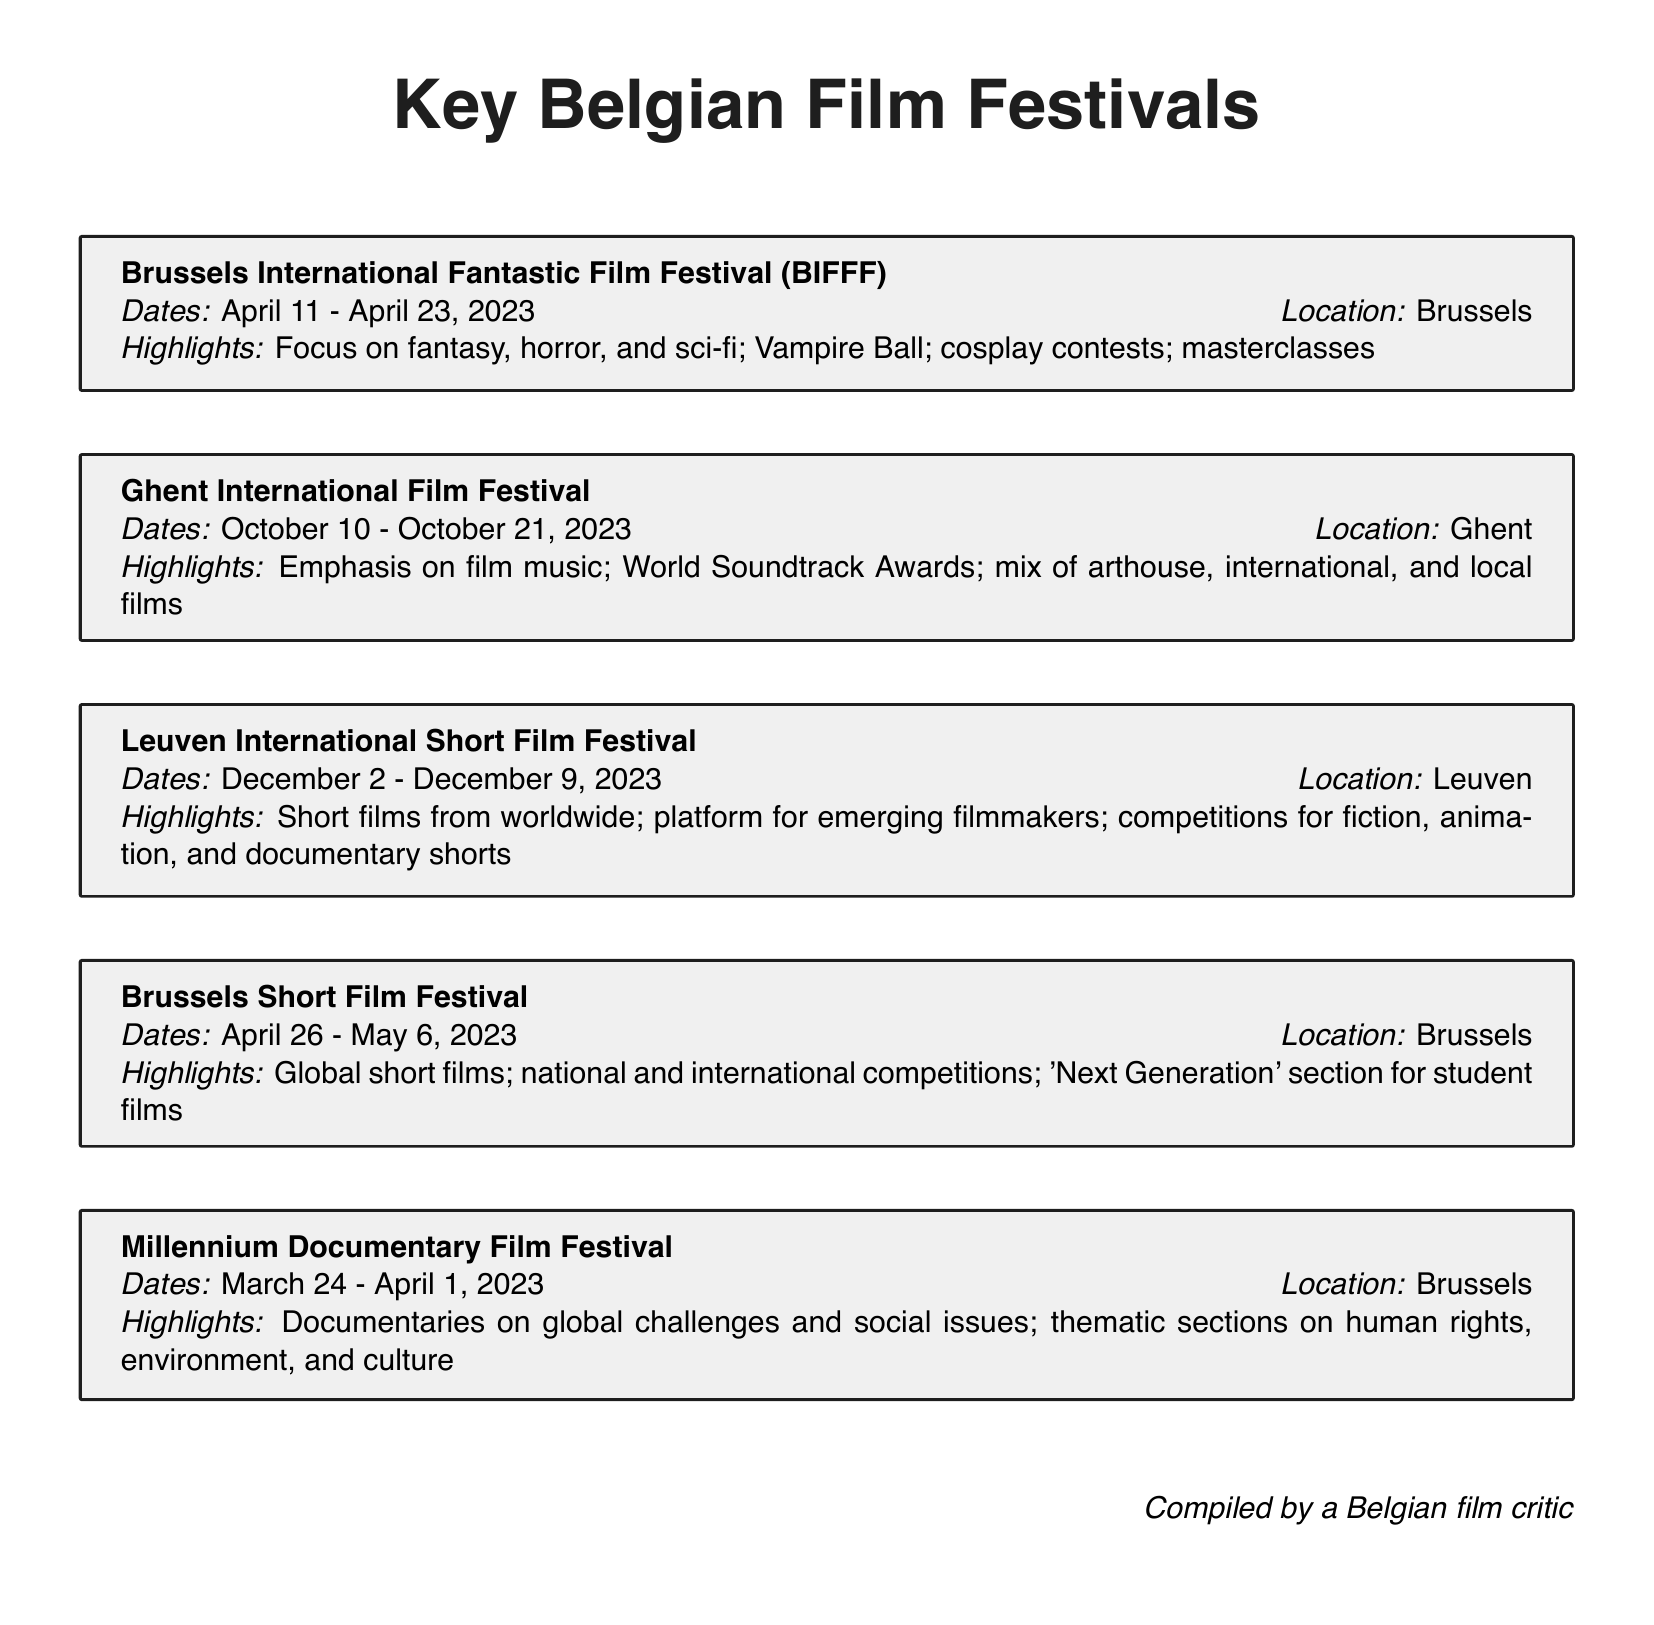What are the dates for the Ghent International Film Festival? The dates for the Ghent International Film Festival can be found in the document and are from October 10 to October 21, 2023.
Answer: October 10 - October 21, 2023 What is the location of the Brussels Short Film Festival? The document mentions the location of the Brussels Short Film Festival, which is Brussels.
Answer: Brussels What highlights are featured in the Brussels International Fantastic Film Festival? The highlights are specified in the document and include a focus on fantasy, horror, and sci-fi, Vampire Ball, cosplay contests, and masterclasses.
Answer: Focus on fantasy, horror, and sci-fi; Vampire Ball; cosplay contests; masterclasses How many film festivals listed take place in Brussels? The document lists the festivals along with their locations; there are two festivals in Brussels: the Brussels International Fantastic Film Festival and the Brussels Short Film Festival.
Answer: 2 What types of films are showcased at the Leuven International Short Film Festival? According to the document, the types of films showcased at this festival include short films from worldwide, specifically in fiction, animation, and documentary shorts.
Answer: Short films from worldwide; fiction, animation, and documentary shorts What is the primary focus of the Millennium Documentary Film Festival? The document indicates that the primary focus of this festival is on documentaries related to global challenges and social issues, including themes like human rights, environment, and culture.
Answer: Documentaries on global challenges and social issues When does the Brussels Short Film Festival take place? The document provides the dates for the Brussels Short Film Festival, which are April 26 to May 6, 2023.
Answer: April 26 - May 6, 2023 Which festival emphasizes film music? The festival that emphasizes film music is specifically mentioned in the document as the Ghent International Film Festival, highlighted for the World Soundtrack Awards.
Answer: Ghent International Film Festival 